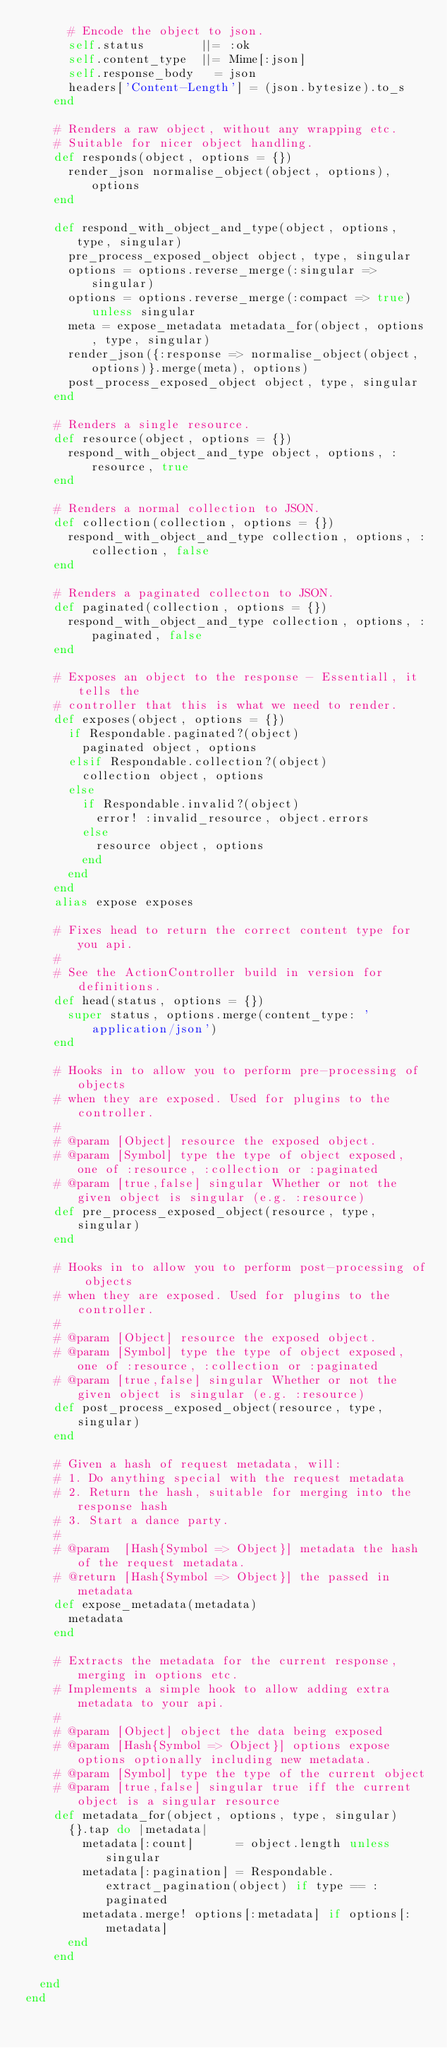Convert code to text. <code><loc_0><loc_0><loc_500><loc_500><_Ruby_>      # Encode the object to json.
      self.status        ||= :ok
      self.content_type  ||= Mime[:json]
      self.response_body   = json
      headers['Content-Length'] = (json.bytesize).to_s
    end

    # Renders a raw object, without any wrapping etc.
    # Suitable for nicer object handling.
    def responds(object, options = {})
      render_json normalise_object(object, options), options
    end

    def respond_with_object_and_type(object, options, type, singular)
      pre_process_exposed_object object, type, singular
      options = options.reverse_merge(:singular => singular)
      options = options.reverse_merge(:compact => true) unless singular
      meta = expose_metadata metadata_for(object, options, type, singular)
      render_json({:response => normalise_object(object, options)}.merge(meta), options)
      post_process_exposed_object object, type, singular
    end

    # Renders a single resource.
    def resource(object, options = {})
      respond_with_object_and_type object, options, :resource, true
    end

    # Renders a normal collection to JSON.
    def collection(collection, options = {})
      respond_with_object_and_type collection, options, :collection, false
    end

    # Renders a paginated collecton to JSON.
    def paginated(collection, options = {})
      respond_with_object_and_type collection, options, :paginated, false
    end

    # Exposes an object to the response - Essentiall, it tells the
    # controller that this is what we need to render.
    def exposes(object, options = {})
      if Respondable.paginated?(object)
        paginated object, options
      elsif Respondable.collection?(object)
        collection object, options
      else
        if Respondable.invalid?(object)
          error! :invalid_resource, object.errors
        else
          resource object, options
        end
      end
    end
    alias expose exposes

    # Fixes head to return the correct content type for you api.
    #
    # See the ActionController build in version for definitions.
    def head(status, options = {})
      super status, options.merge(content_type: 'application/json')
    end

    # Hooks in to allow you to perform pre-processing of objects
    # when they are exposed. Used for plugins to the controller.
    #
    # @param [Object] resource the exposed object.
    # @param [Symbol] type the type of object exposed, one of :resource, :collection or :paginated
    # @param [true,false] singular Whether or not the given object is singular (e.g. :resource)
    def pre_process_exposed_object(resource, type, singular)
    end

    # Hooks in to allow you to perform post-processing of objects
    # when they are exposed. Used for plugins to the controller.
    #
    # @param [Object] resource the exposed object.
    # @param [Symbol] type the type of object exposed, one of :resource, :collection or :paginated
    # @param [true,false] singular Whether or not the given object is singular (e.g. :resource)
    def post_process_exposed_object(resource, type, singular)
    end

    # Given a hash of request metadata, will:
    # 1. Do anything special with the request metadata
    # 2. Return the hash, suitable for merging into the response hash
    # 3. Start a dance party.
    #
    # @param  [Hash{Symbol => Object}] metadata the hash of the request metadata.
    # @return [Hash{Symbol => Object}] the passed in metadata
    def expose_metadata(metadata)
      metadata
    end

    # Extracts the metadata for the current response, merging in options etc.
    # Implements a simple hook to allow adding extra metadata to your api.
    #
    # @param [Object] object the data being exposed
    # @param [Hash{Symbol => Object}] options expose options optionally including new metadata.
    # @param [Symbol] type the type of the current object
    # @param [true,false] singular true iff the current object is a singular resource
    def metadata_for(object, options, type, singular)
      {}.tap do |metadata|
        metadata[:count]      = object.length unless singular
        metadata[:pagination] = Respondable.extract_pagination(object) if type == :paginated
        metadata.merge! options[:metadata] if options[:metadata]
      end
    end

  end
end
</code> 